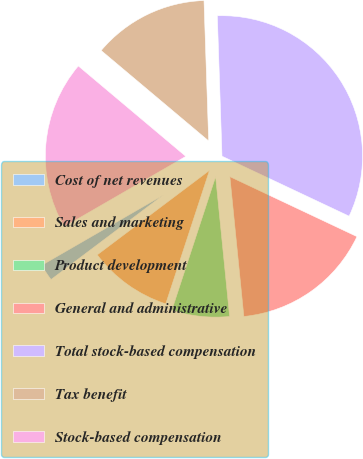<chart> <loc_0><loc_0><loc_500><loc_500><pie_chart><fcel>Cost of net revenues<fcel>Sales and marketing<fcel>Product development<fcel>General and administrative<fcel>Total stock-based compensation<fcel>Tax benefit<fcel>Stock-based compensation<nl><fcel>1.93%<fcel>9.69%<fcel>6.63%<fcel>16.4%<fcel>32.55%<fcel>13.34%<fcel>19.47%<nl></chart> 